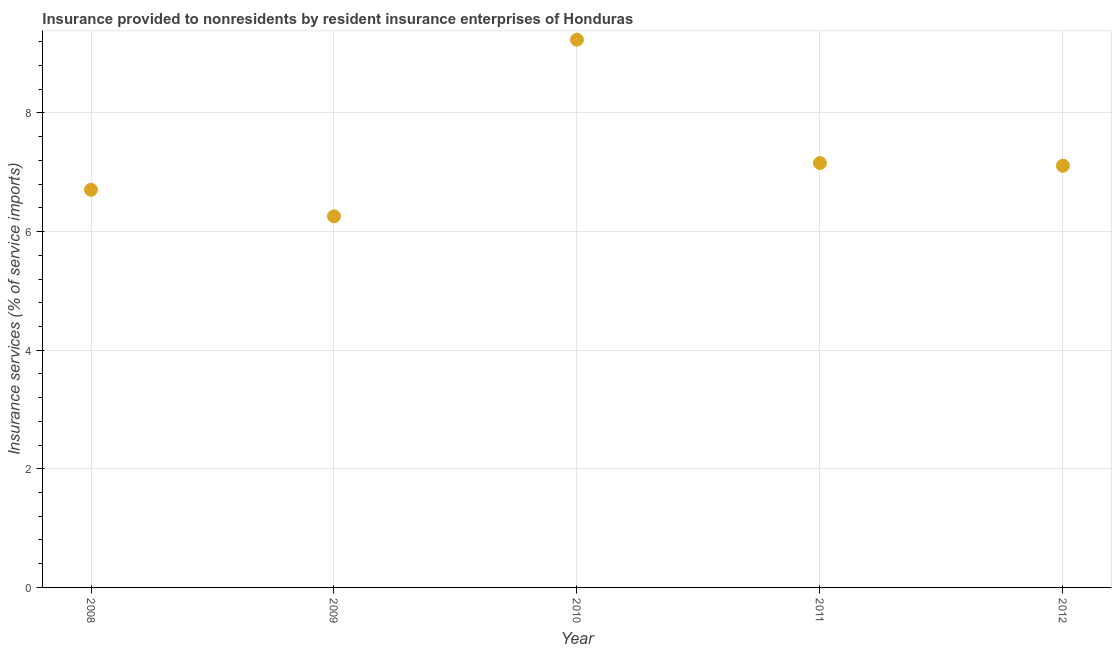What is the insurance and financial services in 2010?
Keep it short and to the point. 9.24. Across all years, what is the maximum insurance and financial services?
Offer a very short reply. 9.24. Across all years, what is the minimum insurance and financial services?
Your response must be concise. 6.26. In which year was the insurance and financial services maximum?
Your response must be concise. 2010. What is the sum of the insurance and financial services?
Ensure brevity in your answer.  36.46. What is the difference between the insurance and financial services in 2010 and 2012?
Offer a very short reply. 2.13. What is the average insurance and financial services per year?
Keep it short and to the point. 7.29. What is the median insurance and financial services?
Make the answer very short. 7.11. In how many years, is the insurance and financial services greater than 7.2 %?
Offer a very short reply. 1. Do a majority of the years between 2011 and 2010 (inclusive) have insurance and financial services greater than 2.8 %?
Provide a short and direct response. No. What is the ratio of the insurance and financial services in 2009 to that in 2010?
Make the answer very short. 0.68. Is the difference between the insurance and financial services in 2008 and 2011 greater than the difference between any two years?
Your answer should be very brief. No. What is the difference between the highest and the second highest insurance and financial services?
Your response must be concise. 2.08. Is the sum of the insurance and financial services in 2009 and 2010 greater than the maximum insurance and financial services across all years?
Your response must be concise. Yes. What is the difference between the highest and the lowest insurance and financial services?
Provide a succinct answer. 2.98. Does the insurance and financial services monotonically increase over the years?
Ensure brevity in your answer.  No. How many years are there in the graph?
Provide a succinct answer. 5. What is the difference between two consecutive major ticks on the Y-axis?
Offer a terse response. 2. Are the values on the major ticks of Y-axis written in scientific E-notation?
Offer a terse response. No. What is the title of the graph?
Keep it short and to the point. Insurance provided to nonresidents by resident insurance enterprises of Honduras. What is the label or title of the X-axis?
Your response must be concise. Year. What is the label or title of the Y-axis?
Offer a terse response. Insurance services (% of service imports). What is the Insurance services (% of service imports) in 2008?
Keep it short and to the point. 6.7. What is the Insurance services (% of service imports) in 2009?
Ensure brevity in your answer.  6.26. What is the Insurance services (% of service imports) in 2010?
Ensure brevity in your answer.  9.24. What is the Insurance services (% of service imports) in 2011?
Your response must be concise. 7.16. What is the Insurance services (% of service imports) in 2012?
Ensure brevity in your answer.  7.11. What is the difference between the Insurance services (% of service imports) in 2008 and 2009?
Offer a terse response. 0.45. What is the difference between the Insurance services (% of service imports) in 2008 and 2010?
Your answer should be compact. -2.53. What is the difference between the Insurance services (% of service imports) in 2008 and 2011?
Make the answer very short. -0.45. What is the difference between the Insurance services (% of service imports) in 2008 and 2012?
Give a very brief answer. -0.41. What is the difference between the Insurance services (% of service imports) in 2009 and 2010?
Your response must be concise. -2.98. What is the difference between the Insurance services (% of service imports) in 2009 and 2011?
Provide a succinct answer. -0.9. What is the difference between the Insurance services (% of service imports) in 2009 and 2012?
Keep it short and to the point. -0.85. What is the difference between the Insurance services (% of service imports) in 2010 and 2011?
Offer a terse response. 2.08. What is the difference between the Insurance services (% of service imports) in 2010 and 2012?
Your response must be concise. 2.13. What is the difference between the Insurance services (% of service imports) in 2011 and 2012?
Your response must be concise. 0.04. What is the ratio of the Insurance services (% of service imports) in 2008 to that in 2009?
Your response must be concise. 1.07. What is the ratio of the Insurance services (% of service imports) in 2008 to that in 2010?
Ensure brevity in your answer.  0.73. What is the ratio of the Insurance services (% of service imports) in 2008 to that in 2011?
Offer a very short reply. 0.94. What is the ratio of the Insurance services (% of service imports) in 2008 to that in 2012?
Your answer should be very brief. 0.94. What is the ratio of the Insurance services (% of service imports) in 2009 to that in 2010?
Provide a short and direct response. 0.68. What is the ratio of the Insurance services (% of service imports) in 2009 to that in 2011?
Provide a succinct answer. 0.87. What is the ratio of the Insurance services (% of service imports) in 2010 to that in 2011?
Your answer should be very brief. 1.29. What is the ratio of the Insurance services (% of service imports) in 2010 to that in 2012?
Your response must be concise. 1.3. What is the ratio of the Insurance services (% of service imports) in 2011 to that in 2012?
Offer a very short reply. 1.01. 